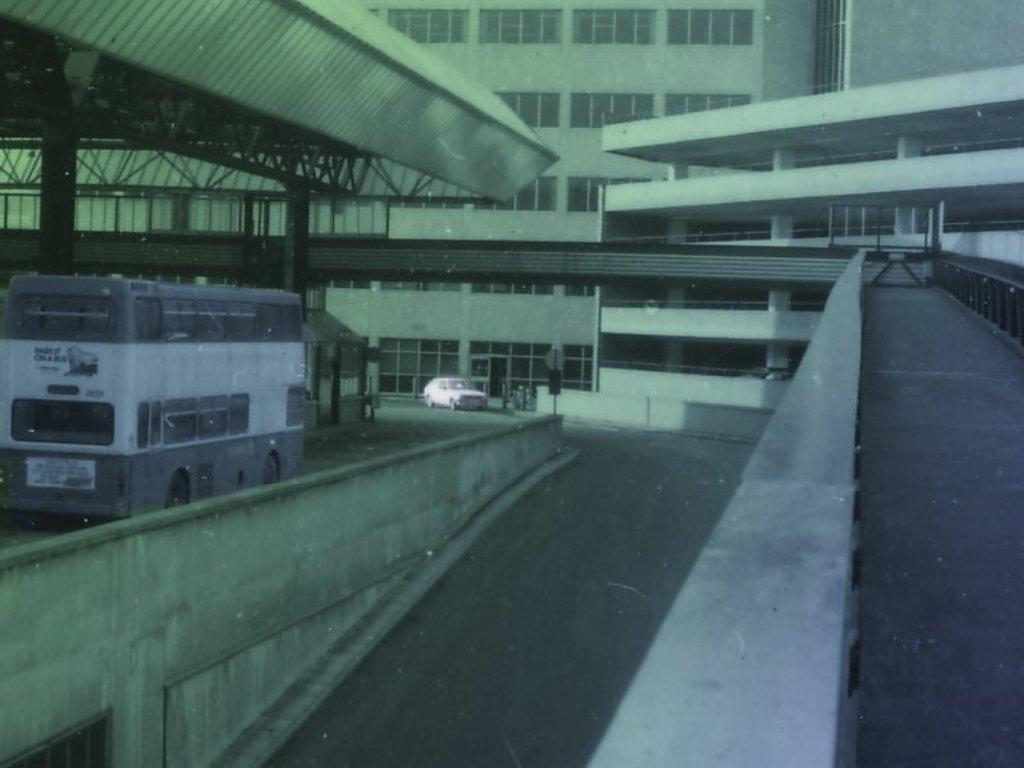What type of vehicle is present in the image? There is a bus in the image. Are there any other vehicles in the image? Yes, there is a car in the image. Where are the bus and car located? The bus and car are on a road in the image. What else can be seen in the image besides vehicles? There are buildings in the image, and the buildings have windows. What part of the buildings is visible in the image? There is a roof visible in the image. Where is the family shopping in the image? There is no family or market present in the image; it features a bus, a car, and buildings. What type of lamp is hanging from the bus in the image? There is no lamp present on the bus in the image. 